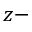<formula> <loc_0><loc_0><loc_500><loc_500>z -</formula> 